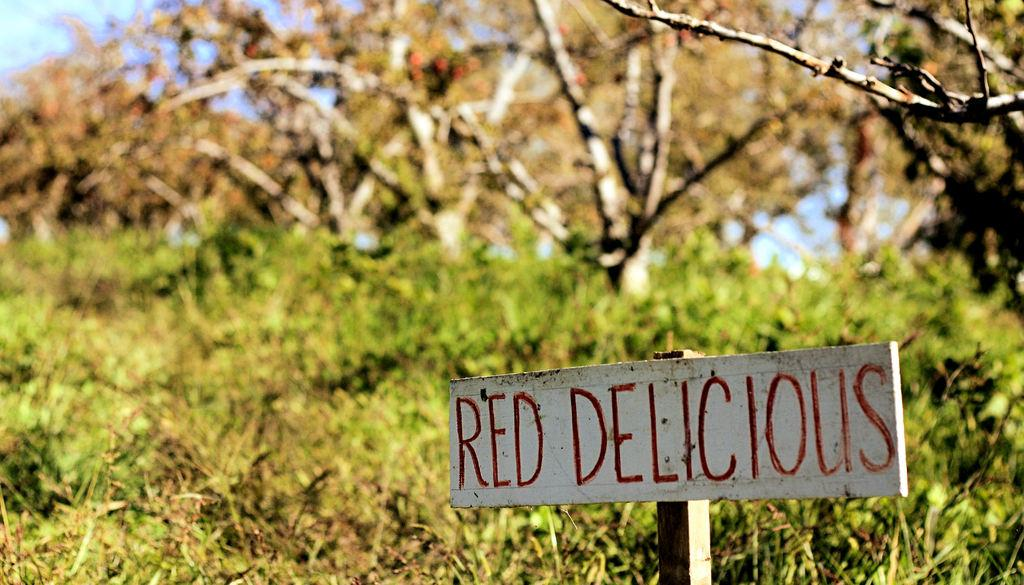What type of vegetation can be seen in the image? There are plants and trees in the image. What part of the natural element is visible in the image? The sky is visible in the image. What is the purpose of the board with text in the image? The purpose of the board with text is not clear from the image alone, but it may be used for signage or displaying information. Can you hear the zebra in the image? There is no zebra present in the image, so it is not possible to hear one. 